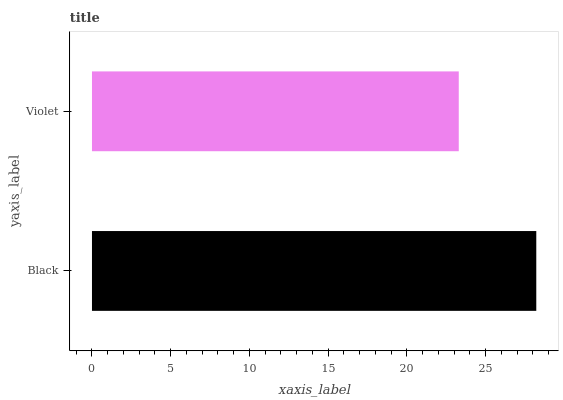Is Violet the minimum?
Answer yes or no. Yes. Is Black the maximum?
Answer yes or no. Yes. Is Violet the maximum?
Answer yes or no. No. Is Black greater than Violet?
Answer yes or no. Yes. Is Violet less than Black?
Answer yes or no. Yes. Is Violet greater than Black?
Answer yes or no. No. Is Black less than Violet?
Answer yes or no. No. Is Black the high median?
Answer yes or no. Yes. Is Violet the low median?
Answer yes or no. Yes. Is Violet the high median?
Answer yes or no. No. Is Black the low median?
Answer yes or no. No. 